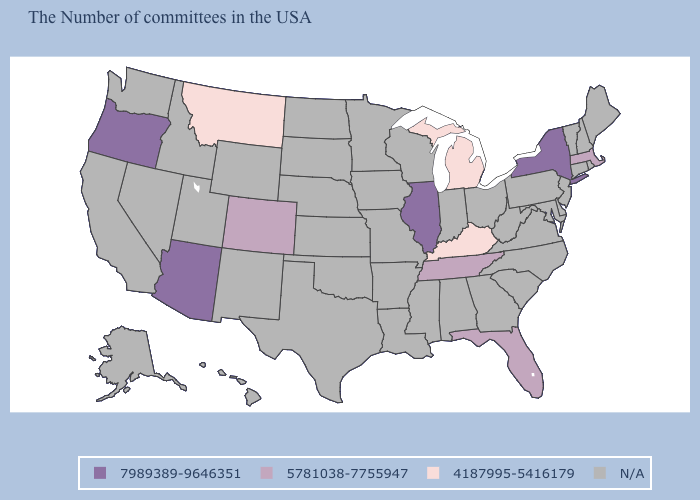Does Montana have the highest value in the USA?
Give a very brief answer. No. Which states have the lowest value in the MidWest?
Quick response, please. Michigan. What is the value of Massachusetts?
Be succinct. 5781038-7755947. Name the states that have a value in the range 5781038-7755947?
Give a very brief answer. Massachusetts, Florida, Tennessee, Colorado. Does the map have missing data?
Quick response, please. Yes. What is the highest value in the Northeast ?
Short answer required. 7989389-9646351. Name the states that have a value in the range 7989389-9646351?
Keep it brief. New York, Illinois, Arizona, Oregon. Name the states that have a value in the range N/A?
Write a very short answer. Maine, Rhode Island, New Hampshire, Vermont, Connecticut, New Jersey, Delaware, Maryland, Pennsylvania, Virginia, North Carolina, South Carolina, West Virginia, Ohio, Georgia, Indiana, Alabama, Wisconsin, Mississippi, Louisiana, Missouri, Arkansas, Minnesota, Iowa, Kansas, Nebraska, Oklahoma, Texas, South Dakota, North Dakota, Wyoming, New Mexico, Utah, Idaho, Nevada, California, Washington, Alaska, Hawaii. Name the states that have a value in the range 5781038-7755947?
Short answer required. Massachusetts, Florida, Tennessee, Colorado. Name the states that have a value in the range N/A?
Answer briefly. Maine, Rhode Island, New Hampshire, Vermont, Connecticut, New Jersey, Delaware, Maryland, Pennsylvania, Virginia, North Carolina, South Carolina, West Virginia, Ohio, Georgia, Indiana, Alabama, Wisconsin, Mississippi, Louisiana, Missouri, Arkansas, Minnesota, Iowa, Kansas, Nebraska, Oklahoma, Texas, South Dakota, North Dakota, Wyoming, New Mexico, Utah, Idaho, Nevada, California, Washington, Alaska, Hawaii. What is the value of South Carolina?
Concise answer only. N/A. What is the value of Florida?
Write a very short answer. 5781038-7755947. Name the states that have a value in the range 5781038-7755947?
Be succinct. Massachusetts, Florida, Tennessee, Colorado. 